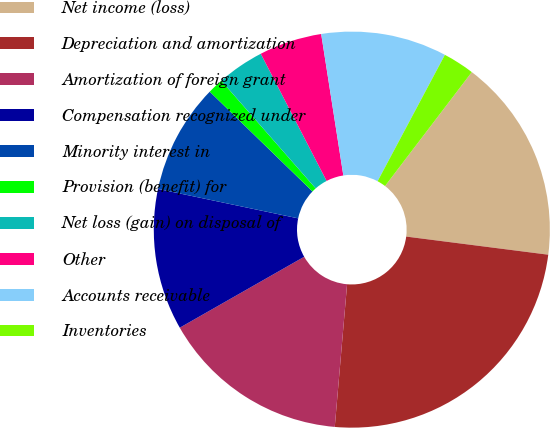Convert chart. <chart><loc_0><loc_0><loc_500><loc_500><pie_chart><fcel>Net income (loss)<fcel>Depreciation and amortization<fcel>Amortization of foreign grant<fcel>Compensation recognized under<fcel>Minority interest in<fcel>Provision (benefit) for<fcel>Net loss (gain) on disposal of<fcel>Other<fcel>Accounts receivable<fcel>Inventories<nl><fcel>16.66%<fcel>24.35%<fcel>15.38%<fcel>11.54%<fcel>8.97%<fcel>1.28%<fcel>3.85%<fcel>5.13%<fcel>10.26%<fcel>2.57%<nl></chart> 